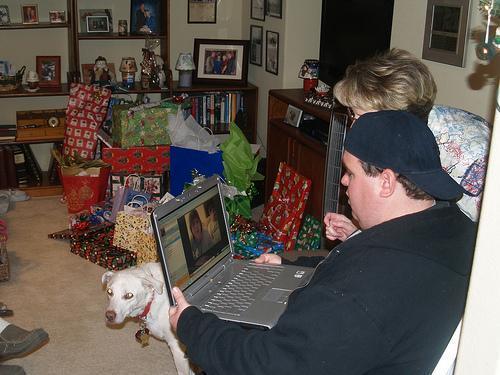How many people are pictured?
Give a very brief answer. 2. How many dogs are visible?
Give a very brief answer. 1. 